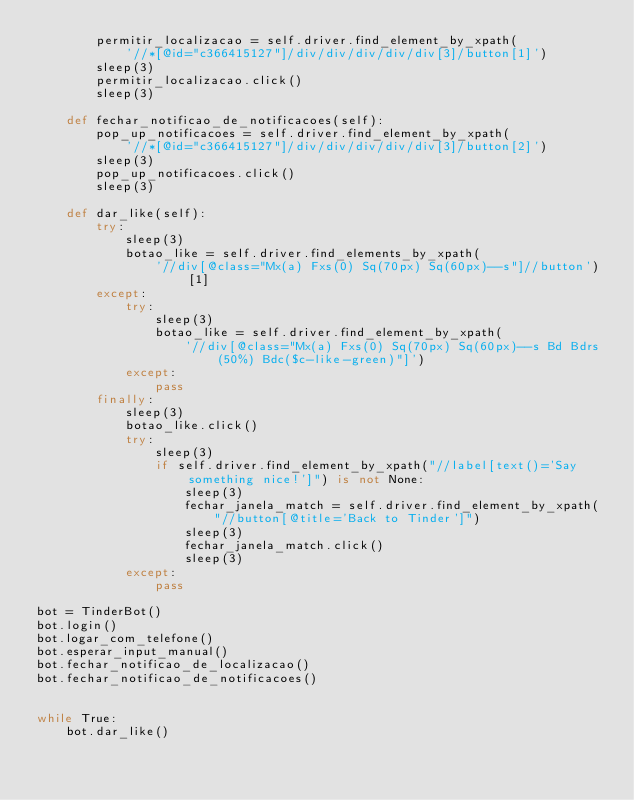<code> <loc_0><loc_0><loc_500><loc_500><_Python_>        permitir_localizacao = self.driver.find_element_by_xpath(
            '//*[@id="c366415127"]/div/div/div/div/div[3]/button[1]')
        sleep(3)
        permitir_localizacao.click()
        sleep(3)

    def fechar_notificao_de_notificacoes(self):
        pop_up_notificacoes = self.driver.find_element_by_xpath(
            '//*[@id="c366415127"]/div/div/div/div/div[3]/button[2]')
        sleep(3)
        pop_up_notificacoes.click()
        sleep(3)

    def dar_like(self):
        try:
            sleep(3)
            botao_like = self.driver.find_elements_by_xpath(
                '//div[@class="Mx(a) Fxs(0) Sq(70px) Sq(60px)--s"]//button')[1]
        except:
            try:
                sleep(3)
                botao_like = self.driver.find_element_by_xpath(
                    '//div[@class="Mx(a) Fxs(0) Sq(70px) Sq(60px)--s Bd Bdrs(50%) Bdc($c-like-green)"]')
            except:
                pass
        finally:
            sleep(3)
            botao_like.click() 
            try:
                sleep(3)
                if self.driver.find_element_by_xpath("//label[text()='Say something nice!']") is not None:
                    sleep(3)
                    fechar_janela_match = self.driver.find_element_by_xpath(
                        "//button[@title='Back to Tinder']")
                    sleep(3)
                    fechar_janela_match.click()
                    sleep(3)
            except:
                pass

bot = TinderBot()
bot.login()
bot.logar_com_telefone()
bot.esperar_input_manual()
bot.fechar_notificao_de_localizacao()
bot.fechar_notificao_de_notificacoes()


while True:
    bot.dar_like()
</code> 